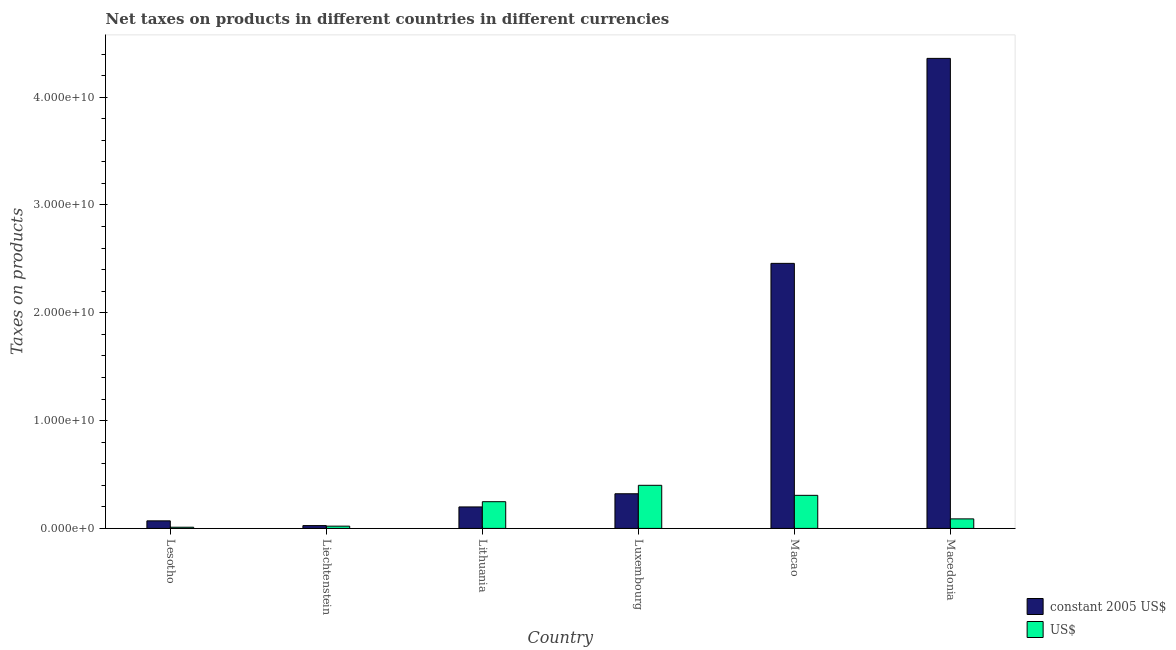Are the number of bars per tick equal to the number of legend labels?
Give a very brief answer. Yes. How many bars are there on the 3rd tick from the right?
Provide a succinct answer. 2. What is the label of the 2nd group of bars from the left?
Your answer should be very brief. Liechtenstein. What is the net taxes in us$ in Macedonia?
Make the answer very short. 8.85e+08. Across all countries, what is the maximum net taxes in constant 2005 us$?
Provide a short and direct response. 4.36e+1. Across all countries, what is the minimum net taxes in constant 2005 us$?
Offer a very short reply. 2.62e+08. In which country was the net taxes in us$ maximum?
Your response must be concise. Luxembourg. In which country was the net taxes in constant 2005 us$ minimum?
Offer a very short reply. Liechtenstein. What is the total net taxes in constant 2005 us$ in the graph?
Give a very brief answer. 7.44e+1. What is the difference between the net taxes in constant 2005 us$ in Lesotho and that in Lithuania?
Ensure brevity in your answer.  -1.29e+09. What is the difference between the net taxes in constant 2005 us$ in Macao and the net taxes in us$ in Macedonia?
Your answer should be very brief. 2.37e+1. What is the average net taxes in us$ per country?
Your answer should be compact. 1.79e+09. What is the difference between the net taxes in constant 2005 us$ and net taxes in us$ in Lesotho?
Keep it short and to the point. 5.91e+08. What is the ratio of the net taxes in us$ in Liechtenstein to that in Lithuania?
Your answer should be compact. 0.08. Is the net taxes in us$ in Liechtenstein less than that in Luxembourg?
Provide a succinct answer. Yes. What is the difference between the highest and the second highest net taxes in us$?
Your response must be concise. 9.29e+08. What is the difference between the highest and the lowest net taxes in us$?
Offer a very short reply. 3.89e+09. What does the 2nd bar from the left in Lithuania represents?
Ensure brevity in your answer.  US$. What does the 1st bar from the right in Macedonia represents?
Provide a short and direct response. US$. How many bars are there?
Your answer should be compact. 12. Are all the bars in the graph horizontal?
Provide a short and direct response. No. How many countries are there in the graph?
Give a very brief answer. 6. What is the difference between two consecutive major ticks on the Y-axis?
Provide a succinct answer. 1.00e+1. Are the values on the major ticks of Y-axis written in scientific E-notation?
Your response must be concise. Yes. Where does the legend appear in the graph?
Provide a succinct answer. Bottom right. How are the legend labels stacked?
Offer a terse response. Vertical. What is the title of the graph?
Give a very brief answer. Net taxes on products in different countries in different currencies. Does "Public credit registry" appear as one of the legend labels in the graph?
Provide a succinct answer. No. What is the label or title of the Y-axis?
Offer a terse response. Taxes on products. What is the Taxes on products in constant 2005 US$ in Lesotho?
Your response must be concise. 7.01e+08. What is the Taxes on products of US$ in Lesotho?
Give a very brief answer. 1.10e+08. What is the Taxes on products in constant 2005 US$ in Liechtenstein?
Offer a very short reply. 2.62e+08. What is the Taxes on products of US$ in Liechtenstein?
Ensure brevity in your answer.  2.10e+08. What is the Taxes on products in constant 2005 US$ in Lithuania?
Your response must be concise. 1.99e+09. What is the Taxes on products in US$ in Lithuania?
Offer a terse response. 2.48e+09. What is the Taxes on products in constant 2005 US$ in Luxembourg?
Provide a succinct answer. 3.21e+09. What is the Taxes on products of US$ in Luxembourg?
Provide a succinct answer. 4.00e+09. What is the Taxes on products in constant 2005 US$ in Macao?
Your answer should be compact. 2.46e+1. What is the Taxes on products in US$ in Macao?
Provide a short and direct response. 3.07e+09. What is the Taxes on products in constant 2005 US$ in Macedonia?
Keep it short and to the point. 4.36e+1. What is the Taxes on products in US$ in Macedonia?
Your answer should be very brief. 8.85e+08. Across all countries, what is the maximum Taxes on products in constant 2005 US$?
Make the answer very short. 4.36e+1. Across all countries, what is the maximum Taxes on products of US$?
Your answer should be compact. 4.00e+09. Across all countries, what is the minimum Taxes on products of constant 2005 US$?
Ensure brevity in your answer.  2.62e+08. Across all countries, what is the minimum Taxes on products in US$?
Offer a very short reply. 1.10e+08. What is the total Taxes on products of constant 2005 US$ in the graph?
Your response must be concise. 7.44e+1. What is the total Taxes on products of US$ in the graph?
Ensure brevity in your answer.  1.08e+1. What is the difference between the Taxes on products in constant 2005 US$ in Lesotho and that in Liechtenstein?
Make the answer very short. 4.39e+08. What is the difference between the Taxes on products in US$ in Lesotho and that in Liechtenstein?
Make the answer very short. -1.00e+08. What is the difference between the Taxes on products of constant 2005 US$ in Lesotho and that in Lithuania?
Provide a short and direct response. -1.29e+09. What is the difference between the Taxes on products of US$ in Lesotho and that in Lithuania?
Offer a very short reply. -2.37e+09. What is the difference between the Taxes on products in constant 2005 US$ in Lesotho and that in Luxembourg?
Give a very brief answer. -2.51e+09. What is the difference between the Taxes on products of US$ in Lesotho and that in Luxembourg?
Offer a very short reply. -3.89e+09. What is the difference between the Taxes on products in constant 2005 US$ in Lesotho and that in Macao?
Your answer should be very brief. -2.39e+1. What is the difference between the Taxes on products of US$ in Lesotho and that in Macao?
Make the answer very short. -2.96e+09. What is the difference between the Taxes on products in constant 2005 US$ in Lesotho and that in Macedonia?
Give a very brief answer. -4.29e+1. What is the difference between the Taxes on products in US$ in Lesotho and that in Macedonia?
Keep it short and to the point. -7.74e+08. What is the difference between the Taxes on products of constant 2005 US$ in Liechtenstein and that in Lithuania?
Your answer should be compact. -1.73e+09. What is the difference between the Taxes on products of US$ in Liechtenstein and that in Lithuania?
Provide a short and direct response. -2.27e+09. What is the difference between the Taxes on products in constant 2005 US$ in Liechtenstein and that in Luxembourg?
Offer a terse response. -2.95e+09. What is the difference between the Taxes on products in US$ in Liechtenstein and that in Luxembourg?
Keep it short and to the point. -3.79e+09. What is the difference between the Taxes on products of constant 2005 US$ in Liechtenstein and that in Macao?
Your response must be concise. -2.43e+1. What is the difference between the Taxes on products of US$ in Liechtenstein and that in Macao?
Your response must be concise. -2.86e+09. What is the difference between the Taxes on products of constant 2005 US$ in Liechtenstein and that in Macedonia?
Your answer should be very brief. -4.33e+1. What is the difference between the Taxes on products of US$ in Liechtenstein and that in Macedonia?
Your answer should be compact. -6.74e+08. What is the difference between the Taxes on products of constant 2005 US$ in Lithuania and that in Luxembourg?
Your answer should be very brief. -1.22e+09. What is the difference between the Taxes on products in US$ in Lithuania and that in Luxembourg?
Offer a very short reply. -1.52e+09. What is the difference between the Taxes on products in constant 2005 US$ in Lithuania and that in Macao?
Your answer should be compact. -2.26e+1. What is the difference between the Taxes on products of US$ in Lithuania and that in Macao?
Make the answer very short. -5.90e+08. What is the difference between the Taxes on products of constant 2005 US$ in Lithuania and that in Macedonia?
Your answer should be very brief. -4.16e+1. What is the difference between the Taxes on products in US$ in Lithuania and that in Macedonia?
Provide a succinct answer. 1.59e+09. What is the difference between the Taxes on products of constant 2005 US$ in Luxembourg and that in Macao?
Provide a succinct answer. -2.14e+1. What is the difference between the Taxes on products in US$ in Luxembourg and that in Macao?
Give a very brief answer. 9.29e+08. What is the difference between the Taxes on products of constant 2005 US$ in Luxembourg and that in Macedonia?
Ensure brevity in your answer.  -4.04e+1. What is the difference between the Taxes on products of US$ in Luxembourg and that in Macedonia?
Give a very brief answer. 3.11e+09. What is the difference between the Taxes on products in constant 2005 US$ in Macao and that in Macedonia?
Make the answer very short. -1.90e+1. What is the difference between the Taxes on products in US$ in Macao and that in Macedonia?
Provide a short and direct response. 2.18e+09. What is the difference between the Taxes on products in constant 2005 US$ in Lesotho and the Taxes on products in US$ in Liechtenstein?
Provide a succinct answer. 4.91e+08. What is the difference between the Taxes on products in constant 2005 US$ in Lesotho and the Taxes on products in US$ in Lithuania?
Offer a terse response. -1.78e+09. What is the difference between the Taxes on products of constant 2005 US$ in Lesotho and the Taxes on products of US$ in Luxembourg?
Keep it short and to the point. -3.30e+09. What is the difference between the Taxes on products of constant 2005 US$ in Lesotho and the Taxes on products of US$ in Macao?
Your response must be concise. -2.37e+09. What is the difference between the Taxes on products in constant 2005 US$ in Lesotho and the Taxes on products in US$ in Macedonia?
Make the answer very short. -1.84e+08. What is the difference between the Taxes on products in constant 2005 US$ in Liechtenstein and the Taxes on products in US$ in Lithuania?
Keep it short and to the point. -2.22e+09. What is the difference between the Taxes on products of constant 2005 US$ in Liechtenstein and the Taxes on products of US$ in Luxembourg?
Ensure brevity in your answer.  -3.74e+09. What is the difference between the Taxes on products of constant 2005 US$ in Liechtenstein and the Taxes on products of US$ in Macao?
Your answer should be very brief. -2.81e+09. What is the difference between the Taxes on products in constant 2005 US$ in Liechtenstein and the Taxes on products in US$ in Macedonia?
Offer a terse response. -6.23e+08. What is the difference between the Taxes on products in constant 2005 US$ in Lithuania and the Taxes on products in US$ in Luxembourg?
Make the answer very short. -2.01e+09. What is the difference between the Taxes on products of constant 2005 US$ in Lithuania and the Taxes on products of US$ in Macao?
Provide a succinct answer. -1.08e+09. What is the difference between the Taxes on products in constant 2005 US$ in Lithuania and the Taxes on products in US$ in Macedonia?
Make the answer very short. 1.11e+09. What is the difference between the Taxes on products of constant 2005 US$ in Luxembourg and the Taxes on products of US$ in Macao?
Give a very brief answer. 1.46e+08. What is the difference between the Taxes on products of constant 2005 US$ in Luxembourg and the Taxes on products of US$ in Macedonia?
Offer a very short reply. 2.33e+09. What is the difference between the Taxes on products in constant 2005 US$ in Macao and the Taxes on products in US$ in Macedonia?
Provide a short and direct response. 2.37e+1. What is the average Taxes on products in constant 2005 US$ per country?
Keep it short and to the point. 1.24e+1. What is the average Taxes on products of US$ per country?
Offer a very short reply. 1.79e+09. What is the difference between the Taxes on products in constant 2005 US$ and Taxes on products in US$ in Lesotho?
Offer a very short reply. 5.91e+08. What is the difference between the Taxes on products in constant 2005 US$ and Taxes on products in US$ in Liechtenstein?
Offer a terse response. 5.15e+07. What is the difference between the Taxes on products of constant 2005 US$ and Taxes on products of US$ in Lithuania?
Provide a succinct answer. -4.86e+08. What is the difference between the Taxes on products in constant 2005 US$ and Taxes on products in US$ in Luxembourg?
Provide a short and direct response. -7.83e+08. What is the difference between the Taxes on products in constant 2005 US$ and Taxes on products in US$ in Macao?
Your answer should be compact. 2.15e+1. What is the difference between the Taxes on products in constant 2005 US$ and Taxes on products in US$ in Macedonia?
Your answer should be very brief. 4.27e+1. What is the ratio of the Taxes on products in constant 2005 US$ in Lesotho to that in Liechtenstein?
Provide a short and direct response. 2.68. What is the ratio of the Taxes on products of US$ in Lesotho to that in Liechtenstein?
Ensure brevity in your answer.  0.52. What is the ratio of the Taxes on products of constant 2005 US$ in Lesotho to that in Lithuania?
Offer a terse response. 0.35. What is the ratio of the Taxes on products of US$ in Lesotho to that in Lithuania?
Give a very brief answer. 0.04. What is the ratio of the Taxes on products in constant 2005 US$ in Lesotho to that in Luxembourg?
Keep it short and to the point. 0.22. What is the ratio of the Taxes on products in US$ in Lesotho to that in Luxembourg?
Provide a succinct answer. 0.03. What is the ratio of the Taxes on products of constant 2005 US$ in Lesotho to that in Macao?
Your response must be concise. 0.03. What is the ratio of the Taxes on products in US$ in Lesotho to that in Macao?
Your response must be concise. 0.04. What is the ratio of the Taxes on products in constant 2005 US$ in Lesotho to that in Macedonia?
Your response must be concise. 0.02. What is the ratio of the Taxes on products in US$ in Lesotho to that in Macedonia?
Offer a terse response. 0.12. What is the ratio of the Taxes on products of constant 2005 US$ in Liechtenstein to that in Lithuania?
Your answer should be compact. 0.13. What is the ratio of the Taxes on products in US$ in Liechtenstein to that in Lithuania?
Ensure brevity in your answer.  0.08. What is the ratio of the Taxes on products in constant 2005 US$ in Liechtenstein to that in Luxembourg?
Keep it short and to the point. 0.08. What is the ratio of the Taxes on products of US$ in Liechtenstein to that in Luxembourg?
Your answer should be compact. 0.05. What is the ratio of the Taxes on products of constant 2005 US$ in Liechtenstein to that in Macao?
Offer a terse response. 0.01. What is the ratio of the Taxes on products of US$ in Liechtenstein to that in Macao?
Your answer should be compact. 0.07. What is the ratio of the Taxes on products of constant 2005 US$ in Liechtenstein to that in Macedonia?
Offer a very short reply. 0.01. What is the ratio of the Taxes on products in US$ in Liechtenstein to that in Macedonia?
Your response must be concise. 0.24. What is the ratio of the Taxes on products in constant 2005 US$ in Lithuania to that in Luxembourg?
Make the answer very short. 0.62. What is the ratio of the Taxes on products in US$ in Lithuania to that in Luxembourg?
Keep it short and to the point. 0.62. What is the ratio of the Taxes on products in constant 2005 US$ in Lithuania to that in Macao?
Provide a short and direct response. 0.08. What is the ratio of the Taxes on products in US$ in Lithuania to that in Macao?
Offer a terse response. 0.81. What is the ratio of the Taxes on products of constant 2005 US$ in Lithuania to that in Macedonia?
Your answer should be very brief. 0.05. What is the ratio of the Taxes on products of US$ in Lithuania to that in Macedonia?
Provide a short and direct response. 2.8. What is the ratio of the Taxes on products of constant 2005 US$ in Luxembourg to that in Macao?
Ensure brevity in your answer.  0.13. What is the ratio of the Taxes on products of US$ in Luxembourg to that in Macao?
Ensure brevity in your answer.  1.3. What is the ratio of the Taxes on products in constant 2005 US$ in Luxembourg to that in Macedonia?
Make the answer very short. 0.07. What is the ratio of the Taxes on products in US$ in Luxembourg to that in Macedonia?
Ensure brevity in your answer.  4.52. What is the ratio of the Taxes on products of constant 2005 US$ in Macao to that in Macedonia?
Offer a terse response. 0.56. What is the ratio of the Taxes on products of US$ in Macao to that in Macedonia?
Ensure brevity in your answer.  3.47. What is the difference between the highest and the second highest Taxes on products of constant 2005 US$?
Provide a short and direct response. 1.90e+1. What is the difference between the highest and the second highest Taxes on products in US$?
Your answer should be very brief. 9.29e+08. What is the difference between the highest and the lowest Taxes on products in constant 2005 US$?
Your answer should be very brief. 4.33e+1. What is the difference between the highest and the lowest Taxes on products of US$?
Offer a terse response. 3.89e+09. 